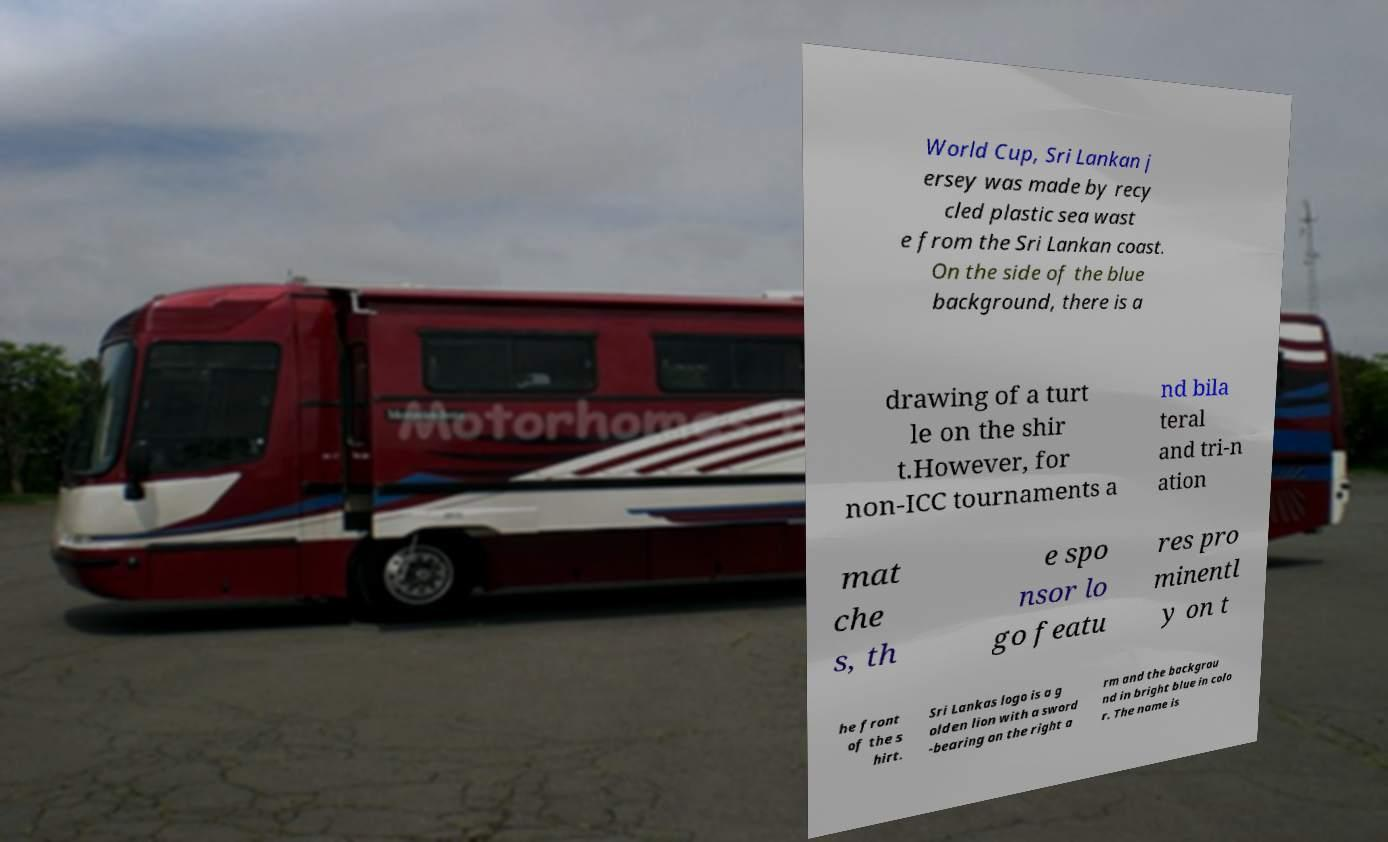Could you extract and type out the text from this image? World Cup, Sri Lankan j ersey was made by recy cled plastic sea wast e from the Sri Lankan coast. On the side of the blue background, there is a drawing of a turt le on the shir t.However, for non-ICC tournaments a nd bila teral and tri-n ation mat che s, th e spo nsor lo go featu res pro minentl y on t he front of the s hirt. Sri Lankas logo is a g olden lion with a sword -bearing on the right a rm and the backgrou nd in bright blue in colo r. The name is 